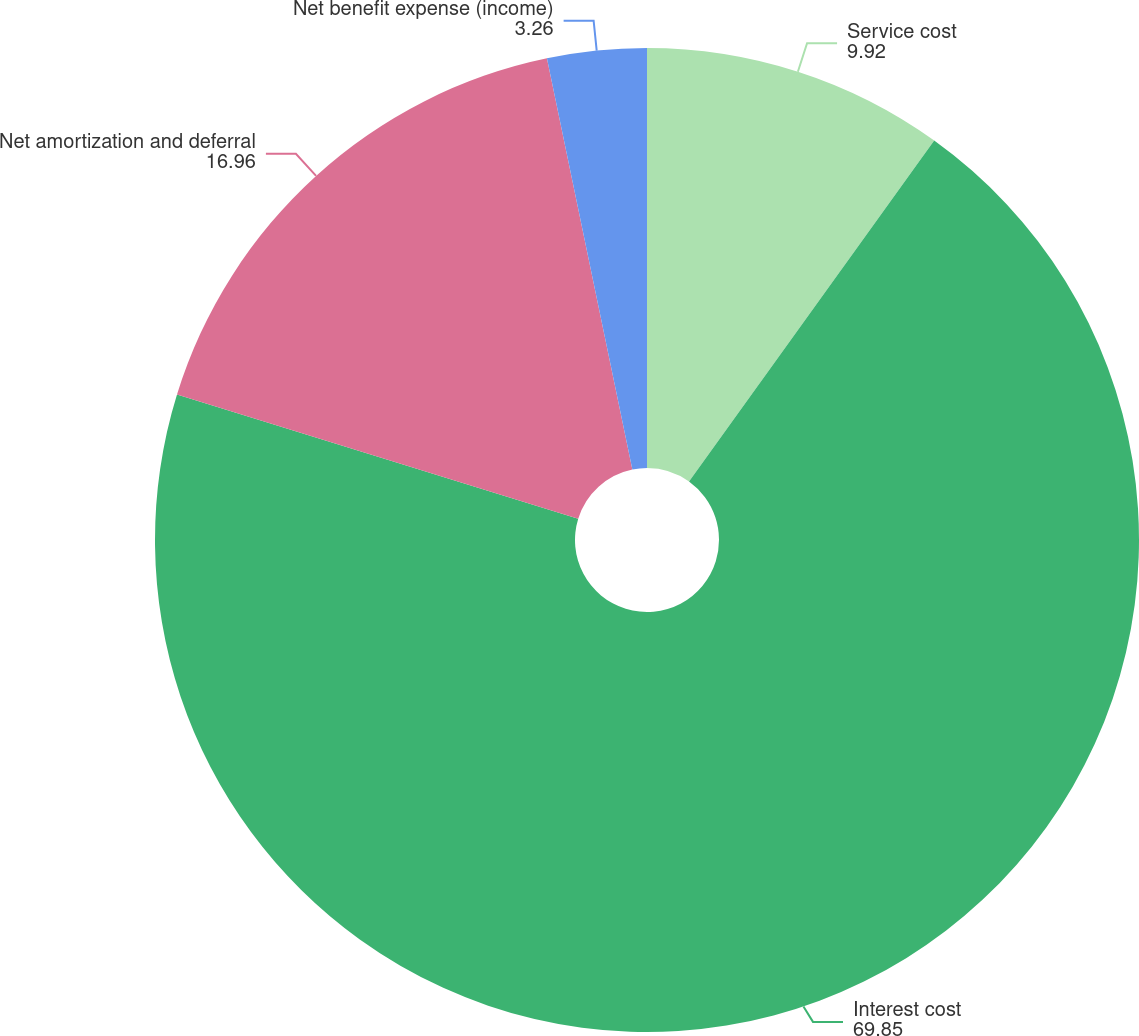Convert chart to OTSL. <chart><loc_0><loc_0><loc_500><loc_500><pie_chart><fcel>Service cost<fcel>Interest cost<fcel>Net amortization and deferral<fcel>Net benefit expense (income)<nl><fcel>9.92%<fcel>69.85%<fcel>16.96%<fcel>3.26%<nl></chart> 